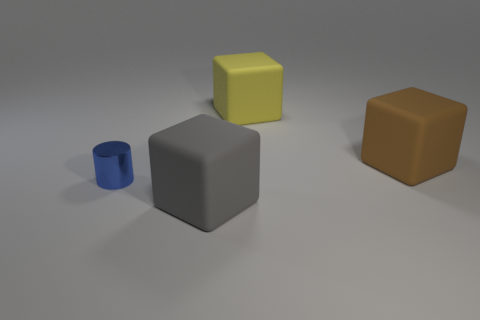Are there any other things that are the same material as the tiny blue cylinder?
Ensure brevity in your answer.  No. What is the small cylinder made of?
Offer a terse response. Metal. There is a large object that is in front of the yellow block and behind the tiny blue metal cylinder; what material is it?
Provide a short and direct response. Rubber. How many objects are matte things that are behind the brown rubber cube or tiny cyan metal things?
Ensure brevity in your answer.  1. Is there another matte block of the same size as the brown matte cube?
Keep it short and to the point. Yes. How many things are in front of the tiny blue metallic thing and behind the blue metallic cylinder?
Provide a short and direct response. 0. There is a yellow rubber block; how many metallic things are right of it?
Your response must be concise. 0. Is there another matte thing that has the same shape as the gray object?
Your answer should be very brief. Yes. Is the shape of the large gray thing the same as the brown matte thing that is in front of the yellow rubber thing?
Your answer should be very brief. Yes. What number of balls are tiny gray things or blue metallic objects?
Your answer should be compact. 0. 